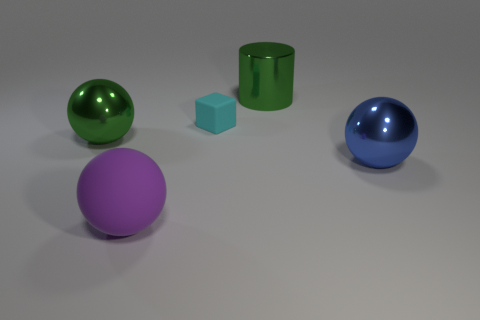Subtract all rubber spheres. How many spheres are left? 2 Add 3 tiny matte cylinders. How many objects exist? 8 Subtract 1 spheres. How many spheres are left? 2 Add 5 blue metallic objects. How many blue metallic objects are left? 6 Add 4 small cyan blocks. How many small cyan blocks exist? 5 Subtract 0 red cubes. How many objects are left? 5 Subtract all balls. How many objects are left? 2 Subtract all cyan balls. Subtract all gray blocks. How many balls are left? 3 Subtract all large green objects. Subtract all rubber blocks. How many objects are left? 2 